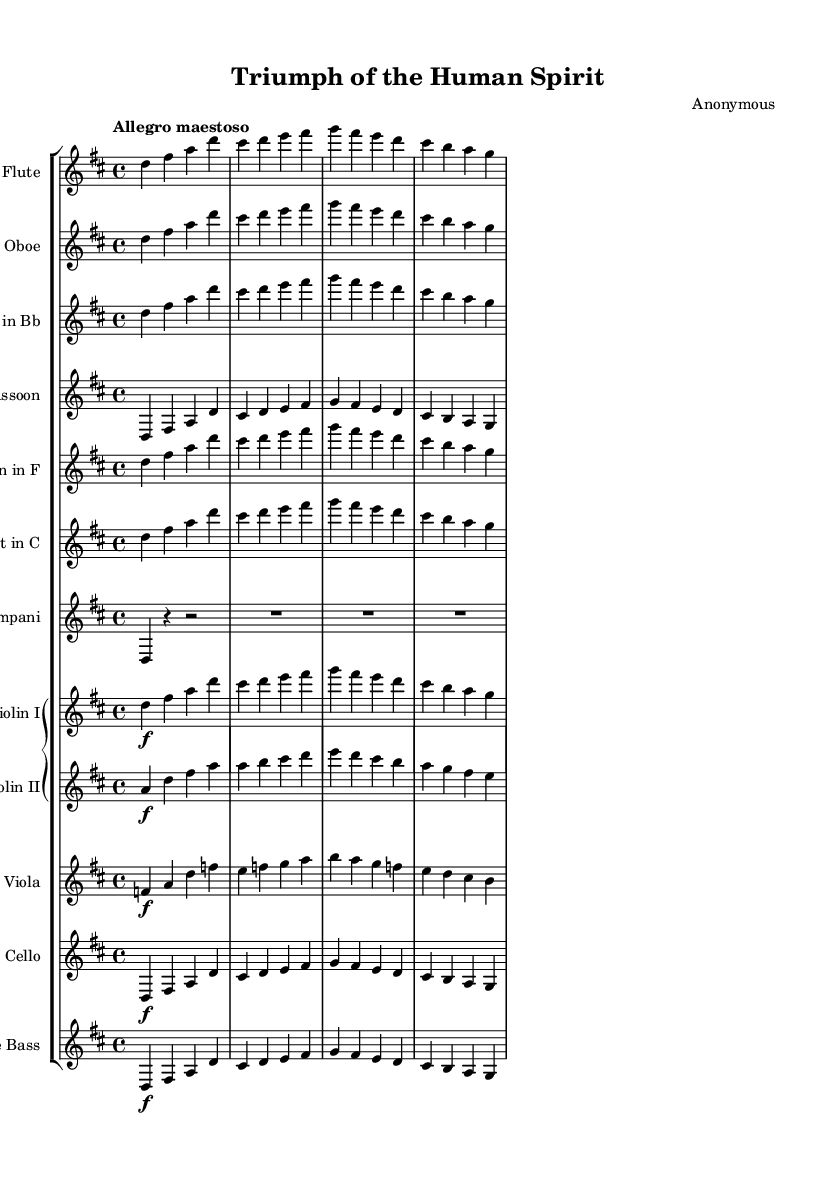What is the key signature of this music? The key signature is indicated with the sharp symbols at the beginning of the staff. In this case, it is D major, which contains two sharps, F# and C#.
Answer: D major What is the time signature of the music? The time signature appears at the beginning of the score, shown as two numbers stacked vertically. Here, it is 4/4, meaning there are four beats in a measure and the quarter note gets one beat.
Answer: 4/4 What is the tempo marking of the piece? The tempo marking is usually indicated at the beginning of the score and describes the speed of the performance. In this case, it states "Allegro maestoso," indicating a fast and majestic tempo.
Answer: Allegro maestoso How many measures are in the provided excerpt? A measure is typically defined by the vertical lines dividing the staff into segments. By counting these divisions in the visible score, we can see there are eight measures present.
Answer: Eight Which instruments are included in this symphony? The instruments are indicated by labels above each staff within the score. The components include flute, oboe, clarinet, bassoon, horn, trumpet, timpani, and strings (violin I, violin II, viola, cello, and double bass).
Answer: Flute, oboe, clarinet, bassoon, horn, trumpet, timpani, violin I, violin II, viola, cello, double bass What does the dynamic marking for the violins indicate? The dynamic marking for the violins is shown as "f," which stands for 'forte,' instructing the musicians to play loudly. This marking is specifically next to the violin I and violin II parts in the sheet music.
Answer: Forte How does the melody relate across different instruments in this excerpt? To understand the relationship in the melody, one should look at the corresponding notes in the staves for each instrument. Here, the flute, oboe, clarinet, bassoon, and strings are playing similar melodic lines, creating a unified thematic idea that emphasizes collective achievement.
Answer: Unified thematic idea 